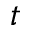<formula> <loc_0><loc_0><loc_500><loc_500>t</formula> 